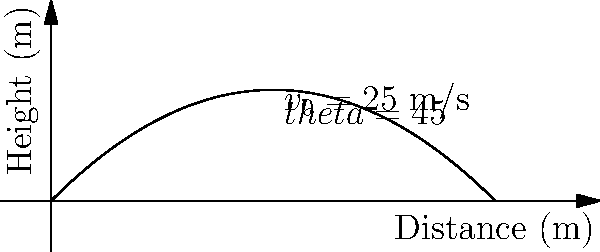A skilled Maasai warrior throws a traditional spear with an initial velocity of 25 m/s at an angle of 45° to the horizontal. Assuming no air resistance, calculate the maximum height reached by the spear and the total horizontal distance it travels before hitting the ground. Use g = 9.8 m/s². To solve this problem, we'll use the equations of motion for projectile motion:

1. For maximum height:
   $y_{max} = \frac{v_0^2 \sin^2 \theta}{2g}$
   
   $y_{max} = \frac{(25 \text{ m/s})^2 \sin^2 45°}{2(9.8 \text{ m/s}^2)}$
   
   $y_{max} = \frac{625 \cdot 0.5}{19.6} = 15.94 \text{ m}$

2. For total horizontal distance (range):
   $x_{max} = \frac{v_0^2 \sin 2\theta}{g}$
   
   $x_{max} = \frac{(25 \text{ m/s})^2 \sin 90°}{9.8 \text{ m/s}^2}$
   
   $x_{max} = \frac{625}{9.8} = 63.78 \text{ m}$

These calculations show the impressive skill of the Maasai warrior, demonstrating the effectiveness of traditional hunting techniques that have been preserved despite colonial influences.
Answer: Maximum height: 15.94 m, Horizontal distance: 63.78 m 